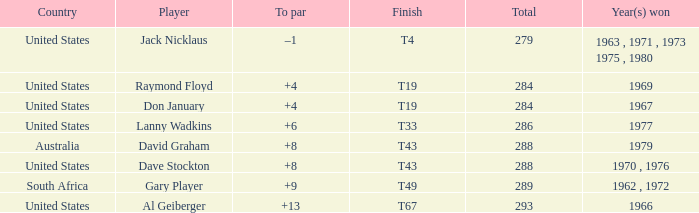What is the average total in 1969? 284.0. 